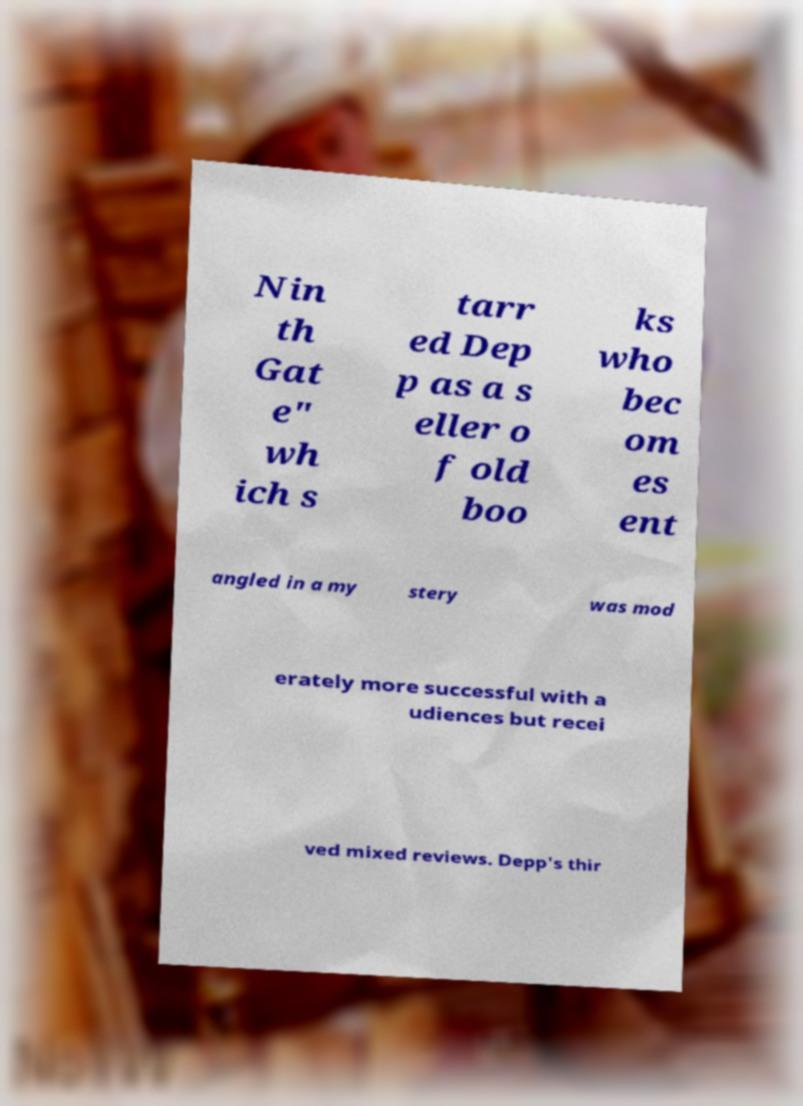Can you accurately transcribe the text from the provided image for me? Nin th Gat e" wh ich s tarr ed Dep p as a s eller o f old boo ks who bec om es ent angled in a my stery was mod erately more successful with a udiences but recei ved mixed reviews. Depp's thir 